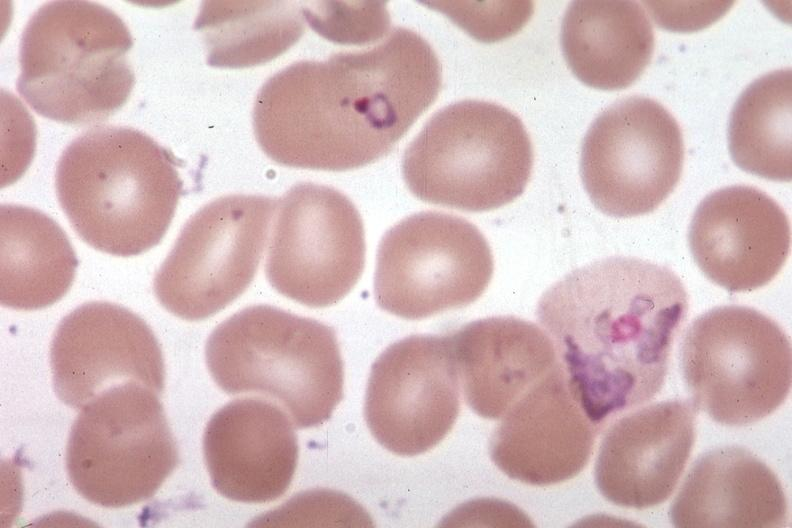s hematologic present?
Answer the question using a single word or phrase. Yes 